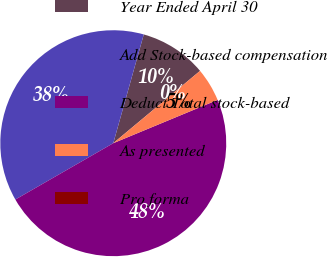Convert chart to OTSL. <chart><loc_0><loc_0><loc_500><loc_500><pie_chart><fcel>Year Ended April 30<fcel>Add Stock-based compensation<fcel>Deduct Total stock-based<fcel>As presented<fcel>Pro forma<nl><fcel>9.59%<fcel>37.66%<fcel>47.95%<fcel>4.8%<fcel>0.0%<nl></chart> 